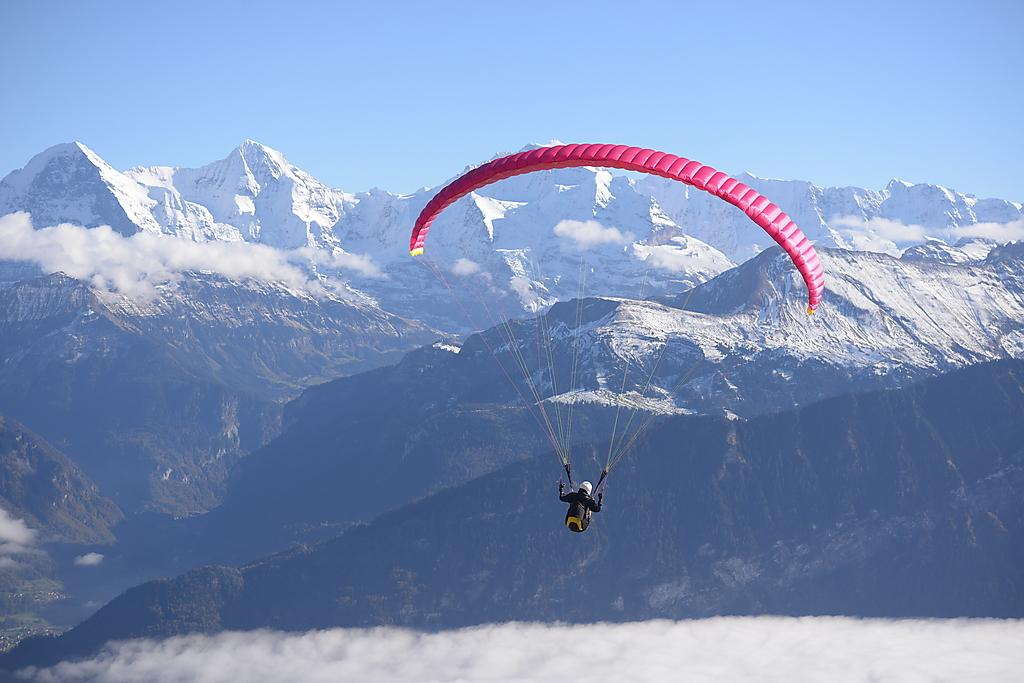What is the main object in the image? There is a parachute in the image. Who is present in the image? There is a man in the image. What can be seen in the background of the image? Hills and the sky are visible in the background of the image. What type of bell can be heard ringing in the image? There is no bell present or ringing in the image. Is there a maid in the image? No, there is no maid present in the image. 